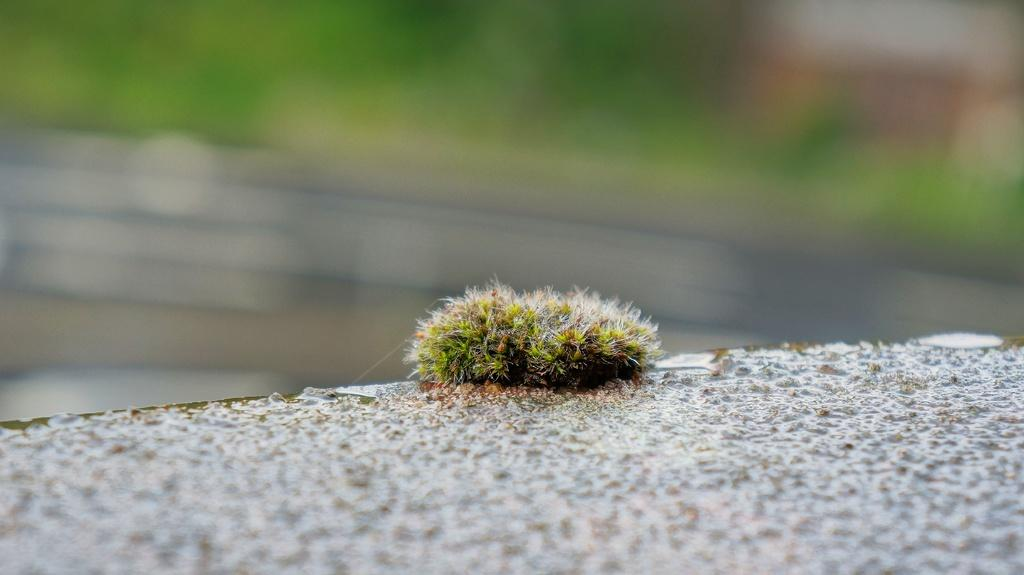What is located in the middle of the image? There is an insect in the middle of the image. What can be said about the color of the insect? The insect is green in color. How many years have the sisters owned the cars in the image? There are no sisters or cars present in the image; it features an insect. 